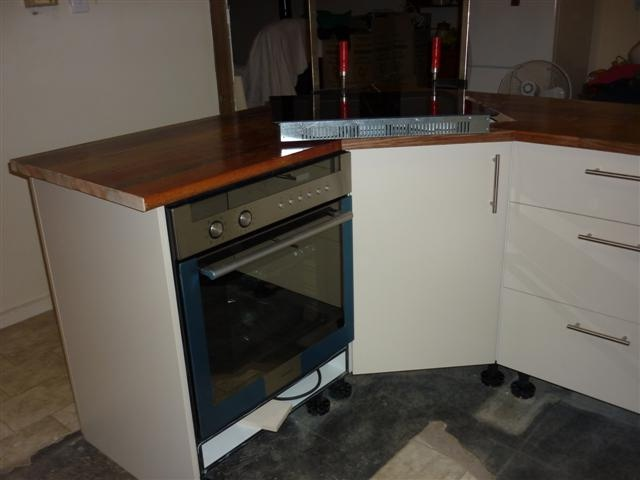Describe the objects in this image and their specific colors. I can see a oven in gray, black, maroon, and darkgray tones in this image. 